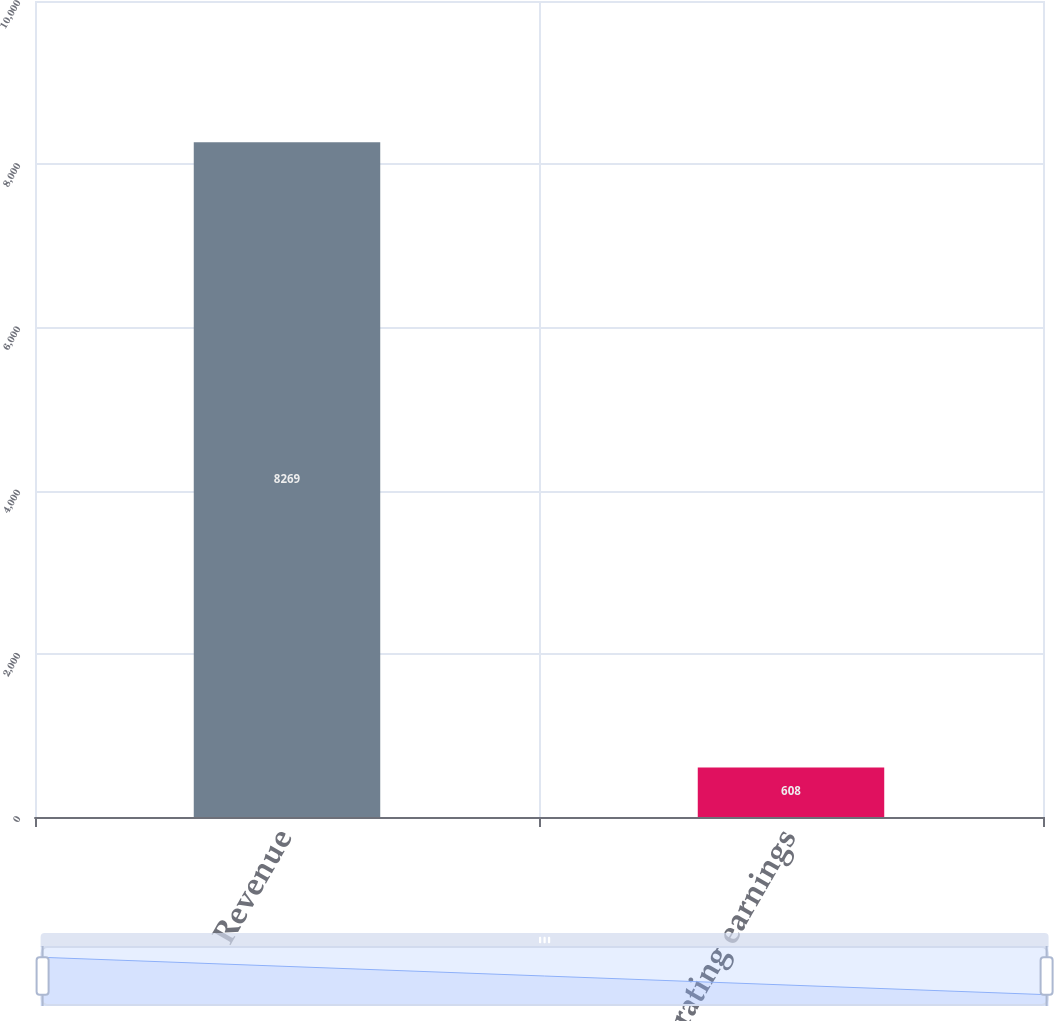<chart> <loc_0><loc_0><loc_500><loc_500><bar_chart><fcel>Revenue<fcel>Operating earnings<nl><fcel>8269<fcel>608<nl></chart> 